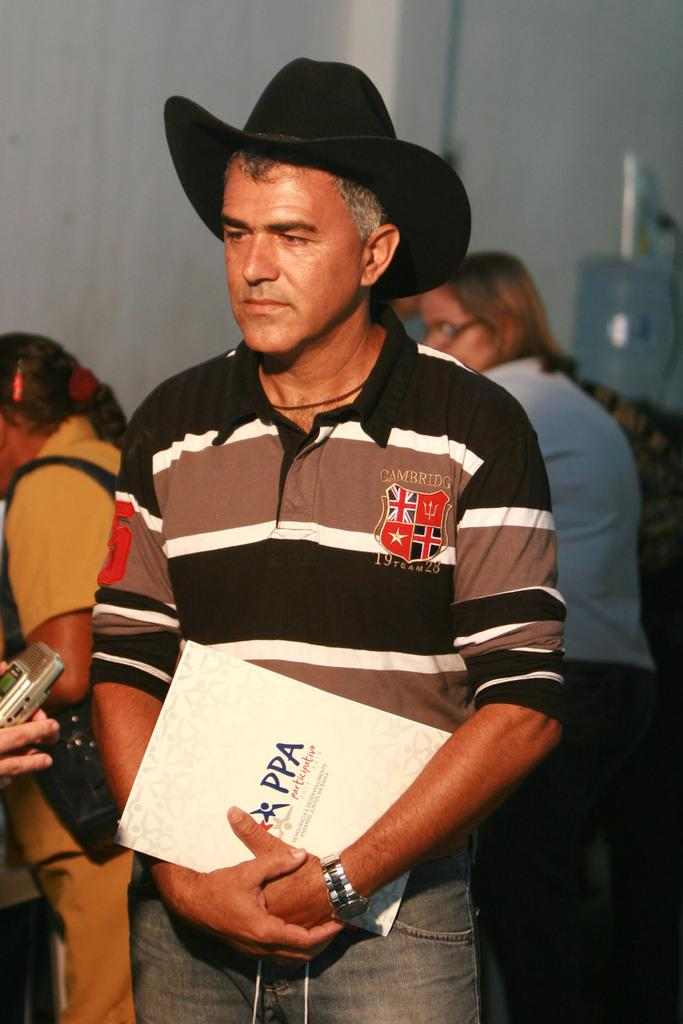What is the main subject of the image? The main subject of the image is a man. What is the man doing in the image? The man is standing in the image. What is the man holding in his hand? The man is holding a book in his hand. What type of clothing is the man wearing on his upper body? The man is wearing a t-shirt. What type of clothing is the man wearing on his lower body? The man is wearing trousers. What type of headwear is the man wearing? The man is wearing a hat. Are there any other people visible in the image? Yes, there are people visible at the back side of the image. What type of memory does the man have in his hand in the image? The man is holding a book in his hand, not a memory. 